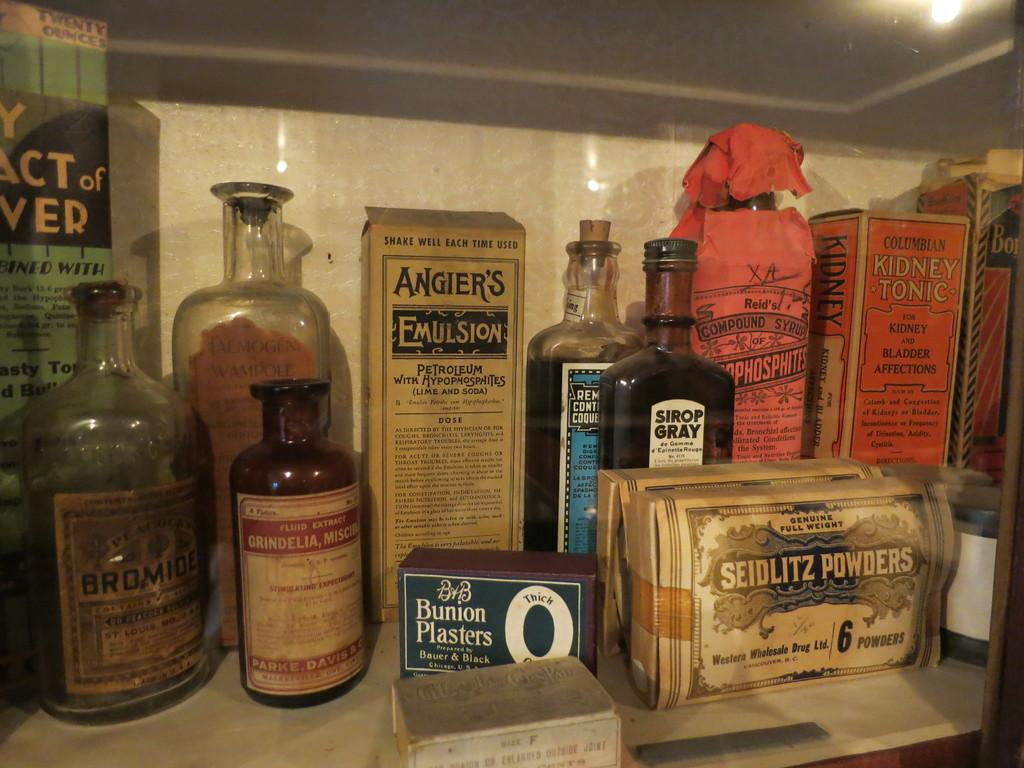Provide a one-sentence caption for the provided image. A collection of very old items including a box of Bunion plasters. 